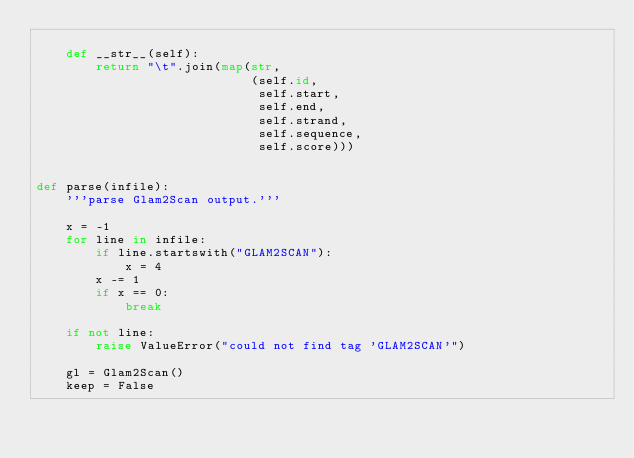<code> <loc_0><loc_0><loc_500><loc_500><_Python_>
    def __str__(self):
        return "\t".join(map(str,
                             (self.id,
                              self.start,
                              self.end,
                              self.strand,
                              self.sequence,
                              self.score)))


def parse(infile):
    '''parse Glam2Scan output.'''

    x = -1
    for line in infile:
        if line.startswith("GLAM2SCAN"):
            x = 4
        x -= 1
        if x == 0:
            break

    if not line:
        raise ValueError("could not find tag 'GLAM2SCAN'")

    gl = Glam2Scan()
    keep = False</code> 